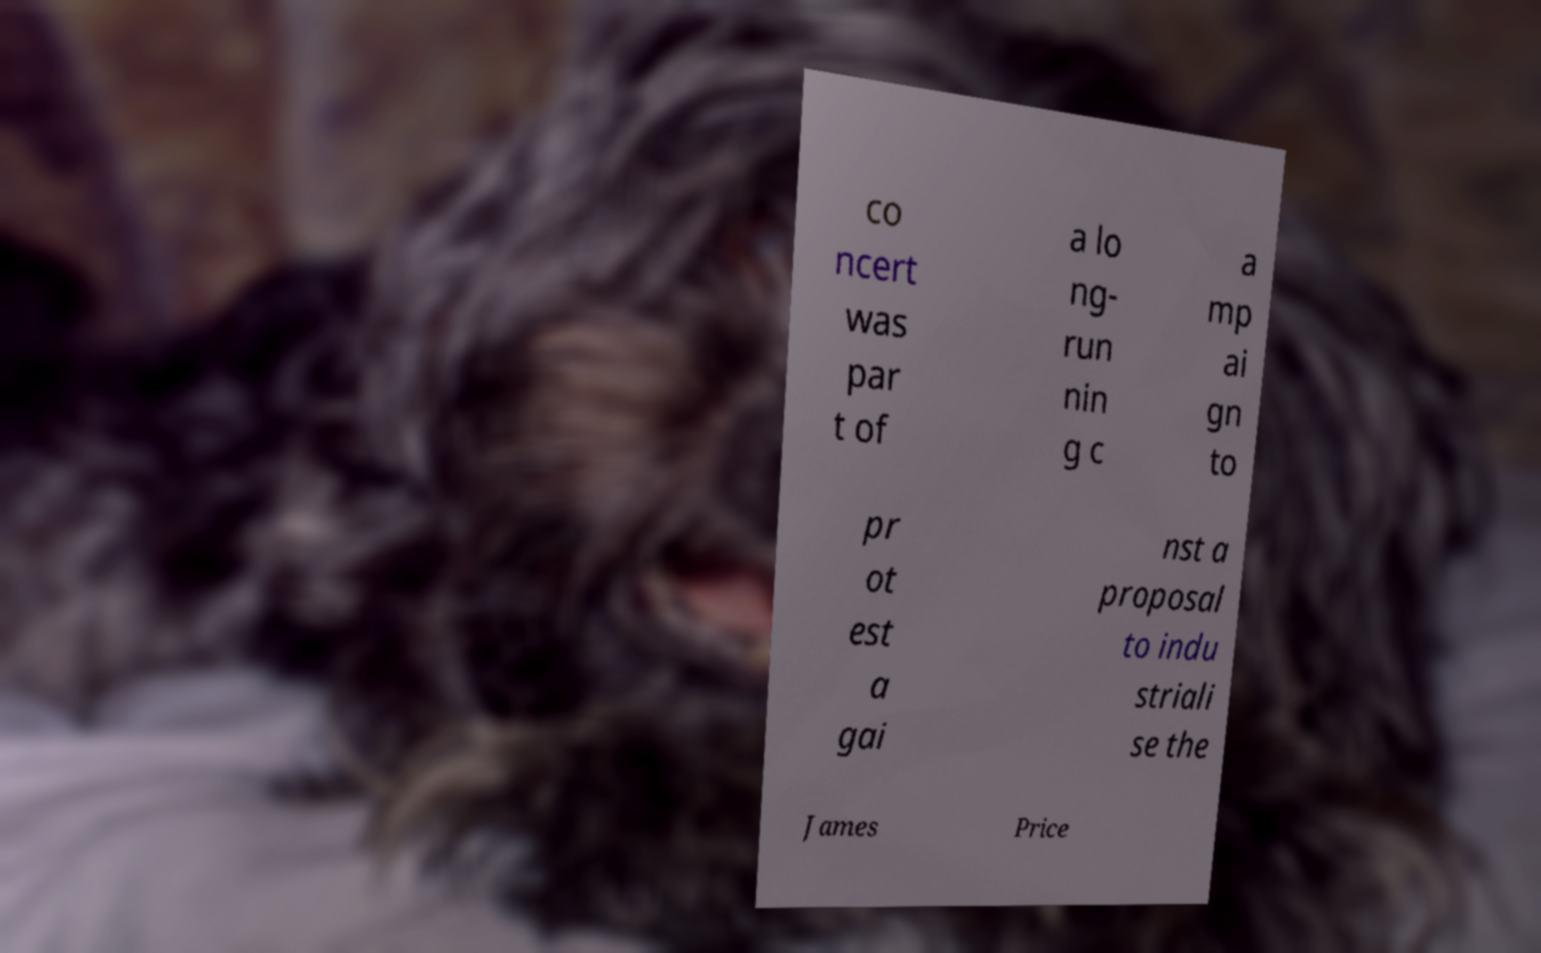Please read and relay the text visible in this image. What does it say? co ncert was par t of a lo ng- run nin g c a mp ai gn to pr ot est a gai nst a proposal to indu striali se the James Price 